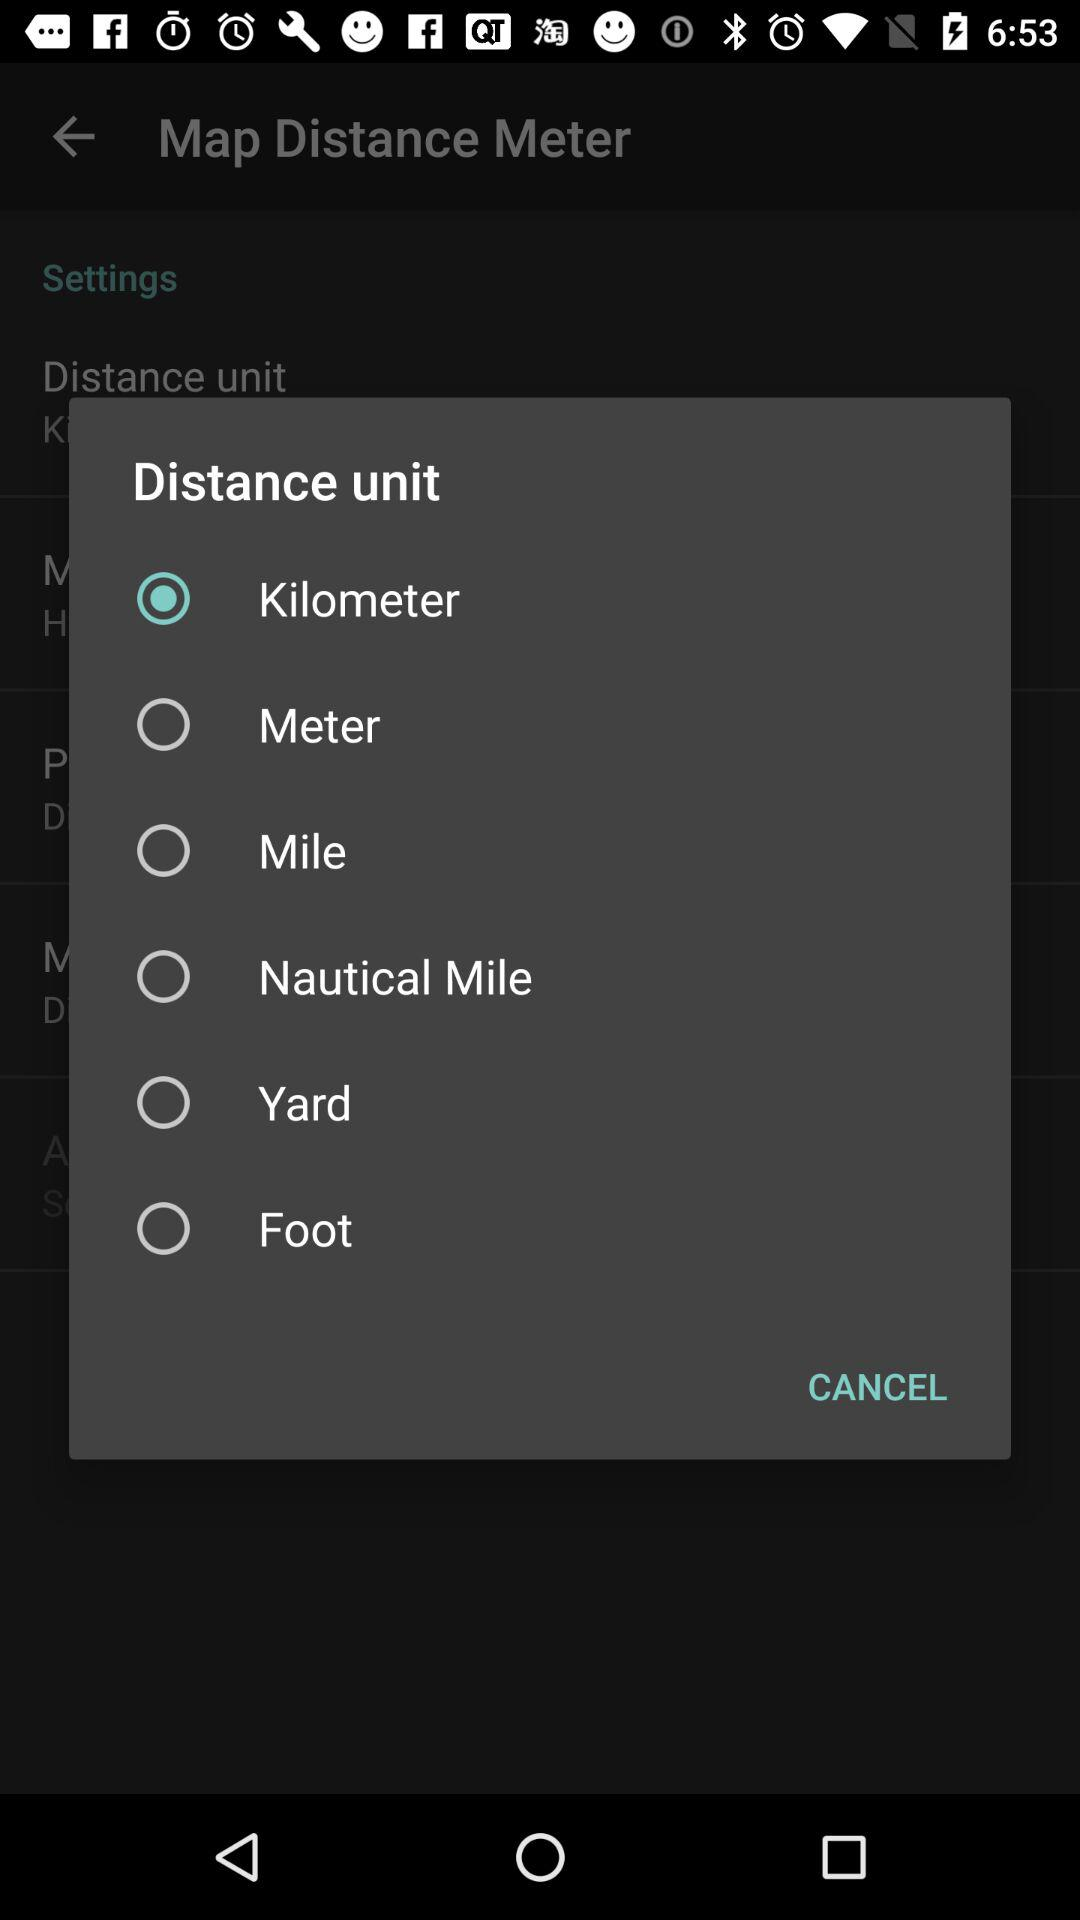Which units are given to measure the distance? The units are kilometer, meter, mile, nautical mile, yard and foot. 